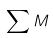<formula> <loc_0><loc_0><loc_500><loc_500>\sum { M }</formula> 